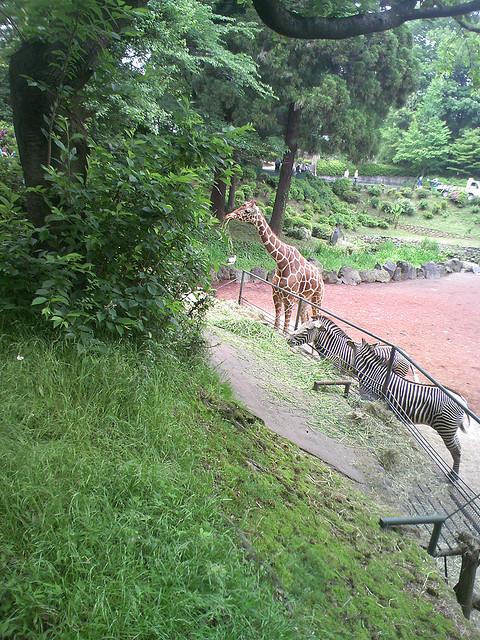Can the giraffe reach the leaves?
Quick response, please. Yes. How many zebras are there?
Write a very short answer. 2. Where are they all going?
Be succinct. To eat. 